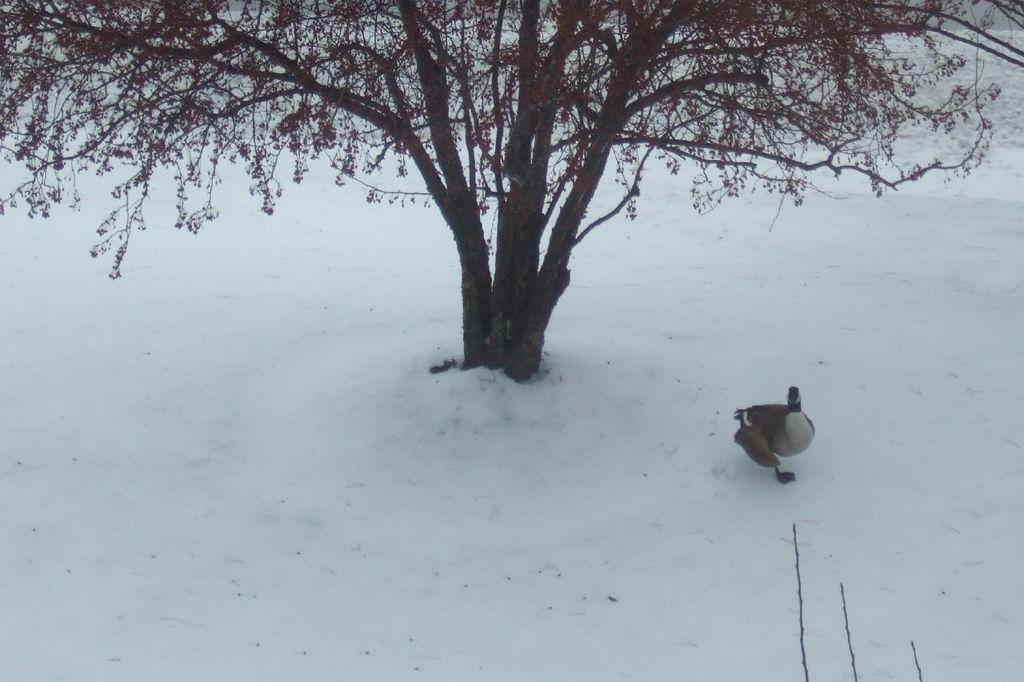What is the primary weather condition depicted in the image? There is snow in the image. What type of animal can be seen in the image? There is a bird in the image. What natural element is present in the image? There is a tree in the image. What type of treatment is the bird undergoing in the image? There is no indication in the image that the bird is undergoing any treatment. What kind of test is being conducted on the tree in the image? There is no test being conducted on the tree in the image. 